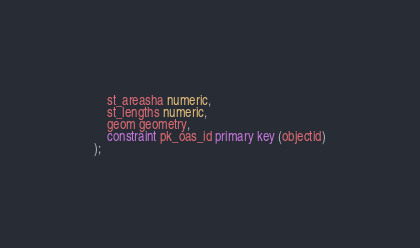Convert code to text. <code><loc_0><loc_0><loc_500><loc_500><_SQL_>    st_areasha numeric,
    st_lengths numeric,
    geom geometry,
    constraint pk_oas_id primary key (objectid)
);</code> 